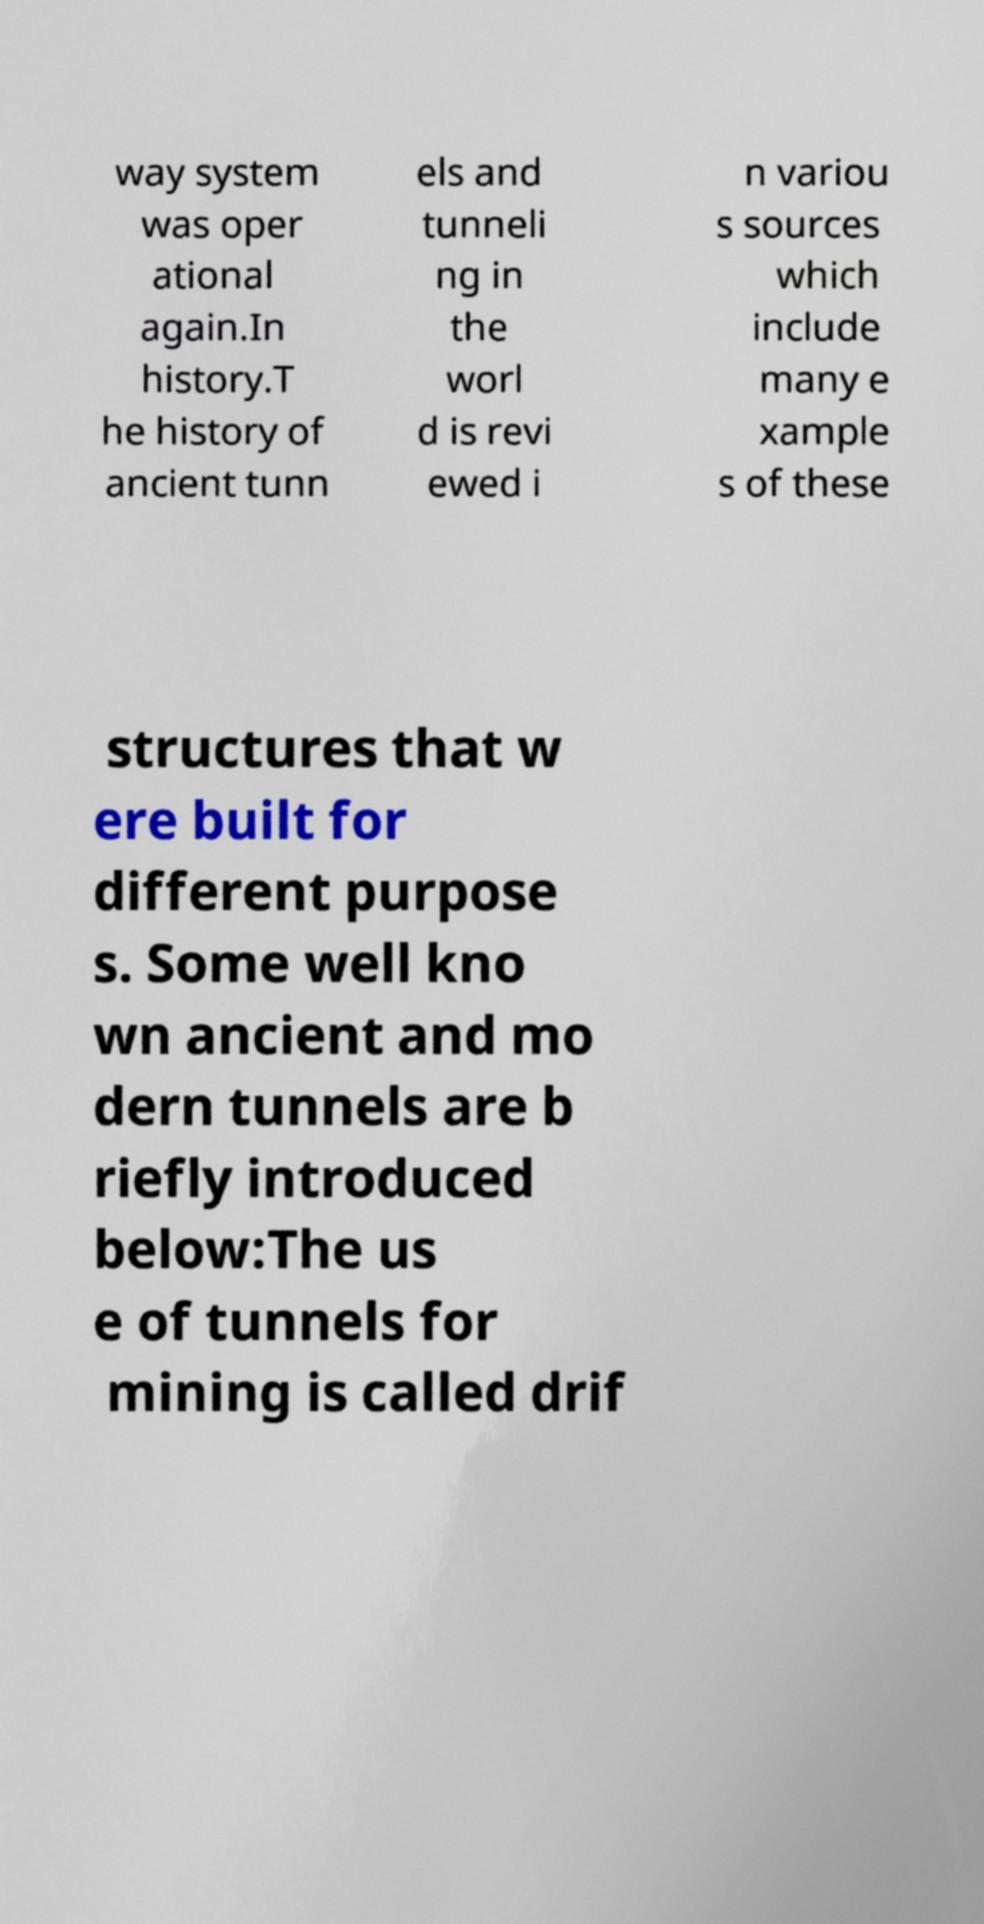Could you assist in decoding the text presented in this image and type it out clearly? way system was oper ational again.In history.T he history of ancient tunn els and tunneli ng in the worl d is revi ewed i n variou s sources which include many e xample s of these structures that w ere built for different purpose s. Some well kno wn ancient and mo dern tunnels are b riefly introduced below:The us e of tunnels for mining is called drif 